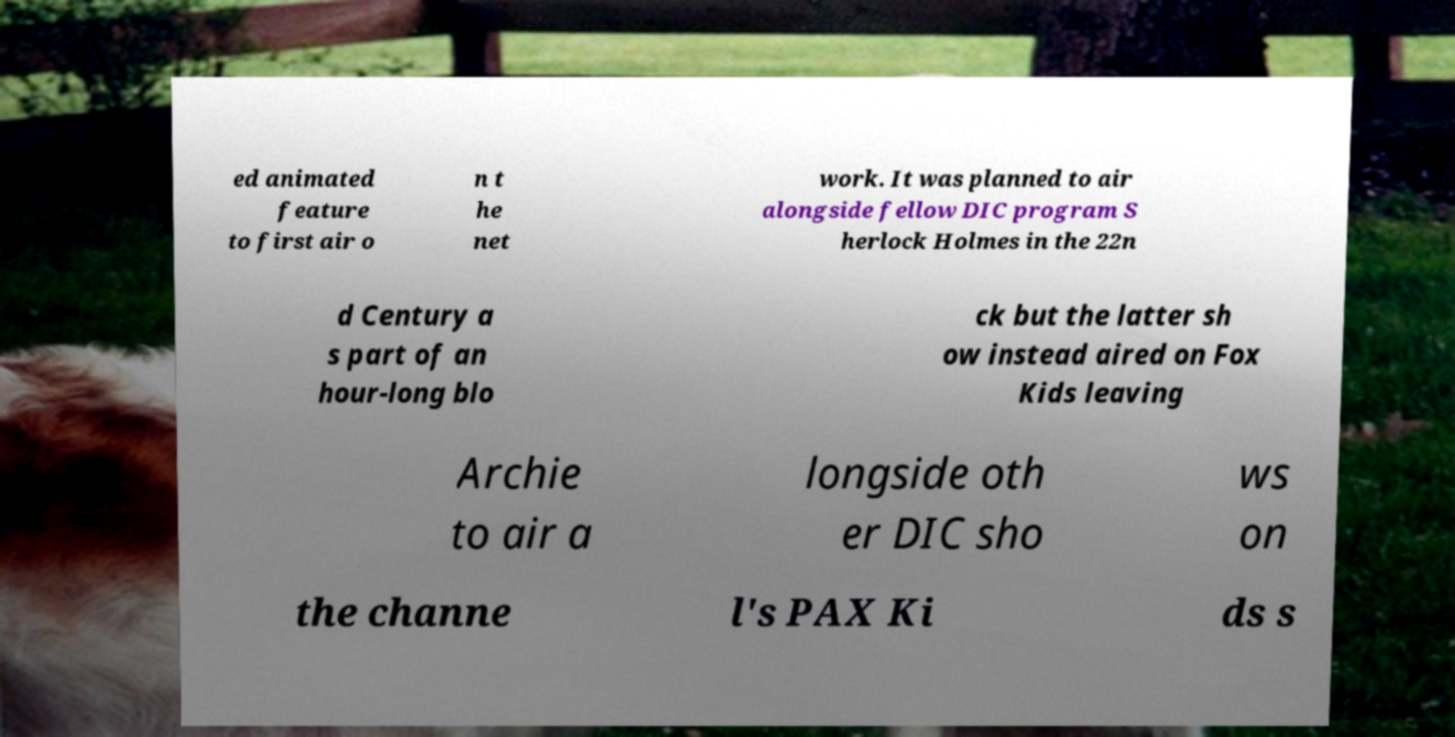Can you accurately transcribe the text from the provided image for me? ed animated feature to first air o n t he net work. It was planned to air alongside fellow DIC program S herlock Holmes in the 22n d Century a s part of an hour-long blo ck but the latter sh ow instead aired on Fox Kids leaving Archie to air a longside oth er DIC sho ws on the channe l's PAX Ki ds s 